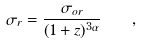Convert formula to latex. <formula><loc_0><loc_0><loc_500><loc_500>\sigma _ { r } = \frac { \sigma _ { o r } } { ( 1 + z ) ^ { 3 \alpha } } \quad ,</formula> 